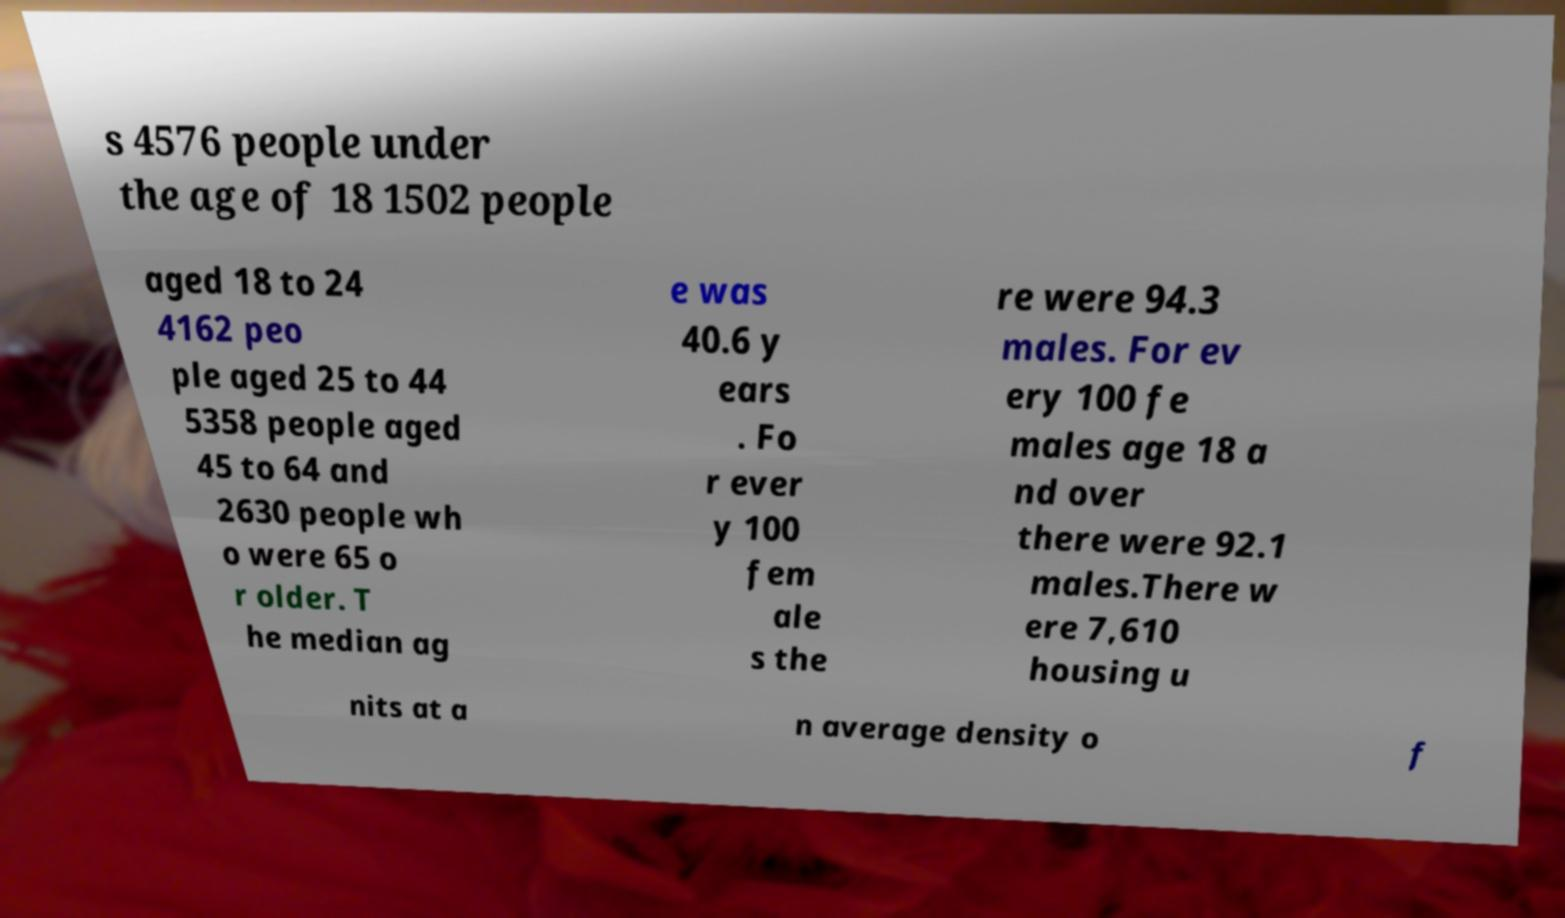Please read and relay the text visible in this image. What does it say? s 4576 people under the age of 18 1502 people aged 18 to 24 4162 peo ple aged 25 to 44 5358 people aged 45 to 64 and 2630 people wh o were 65 o r older. T he median ag e was 40.6 y ears . Fo r ever y 100 fem ale s the re were 94.3 males. For ev ery 100 fe males age 18 a nd over there were 92.1 males.There w ere 7,610 housing u nits at a n average density o f 